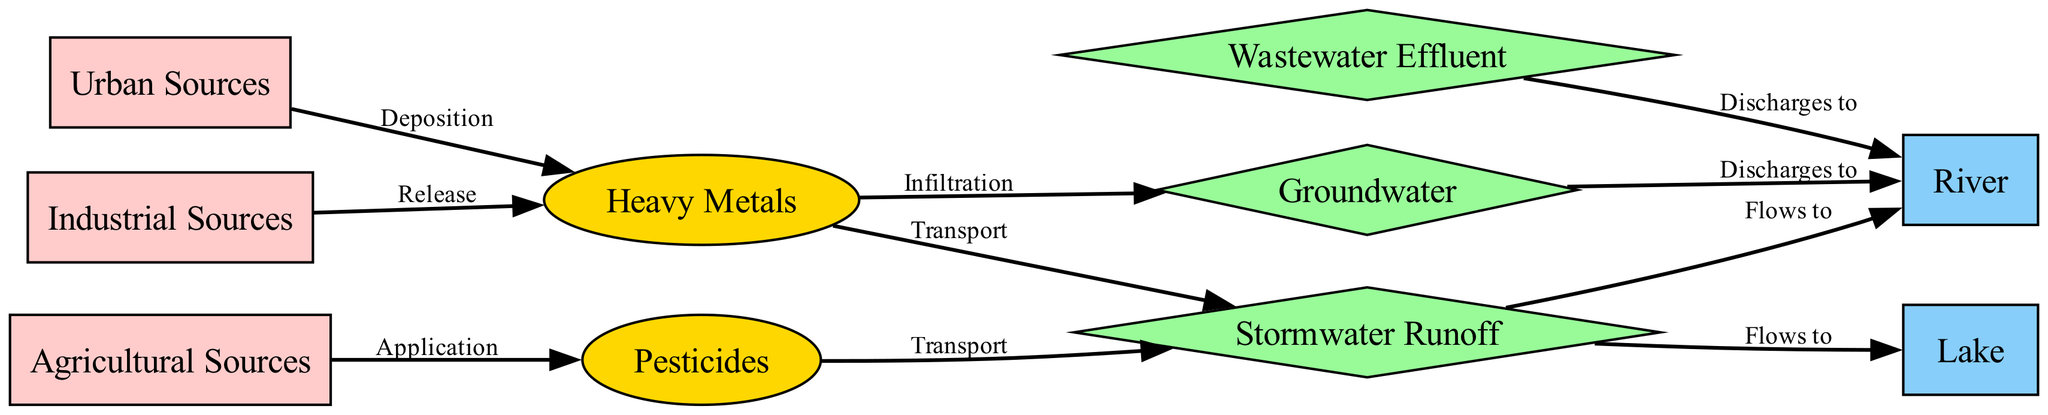What are the three types of sources listed in the diagram? The diagram indicates three types of sources: Industrial Sources, Agricultural Sources, and Urban Sources. These are displayed as nodes labeled clearly as such.
Answer: Industrial Sources, Agricultural Sources, Urban Sources How many contaminants are represented in the diagram? The diagram shows two contaminants: Heavy Metals and Pesticides. These contaminants are represented as distinct nodes in the visual.
Answer: 2 What type of pathway is used for transporting heavy metals? The diagram indicates that Heavy Metals are transported through the pathway labeled as Stormwater Runoff. This relationship is directly depicted by the connecting edge labeled "Transport."
Answer: Stormwater Runoff Which source is associated with pesticide application? According to the diagram, the Agricultural Sources node is linked to Pesticides through the edge labeled "Application," indicating that pesticides come specifically from agricultural practices.
Answer: Agricultural Sources From which pathways do the contaminants flow to the river? The diagram illustrates two pathways discharging into the river: run-off (Stormwater Runoff) and groundwater. The edges labeled "Flows to" and "Discharges to" establish these connections.
Answer: Runoff, Groundwater What contaminants are produced by industrial and urban sources? Industrial Sources release Heavy Metals, while Urban Sources deposit Heavy Metals. Both relationships are directly indicated by edges from their respective source nodes to the Heavy Metals contaminant node in the diagram.
Answer: Heavy Metals Which water bodies are affected by runoff? The diagram indicates that Stormwater Runoff flows into two water bodies: the River and the Lake. This is indicated by directed edges labeled "Flows to."
Answer: River, Lake How does wastewater affect the river? The diagram indicates that Wastewater Effluent discharges into the river, which is depicted by a directed edge labeled "Discharges to." This shows a direct impact of wastewater on the river.
Answer: Discharges to What is the relationship between groundwater and the river? The diagram shows that groundwater discharges into the river, indicated by an edge labeled "Discharges to" that connects the Groundwater node to the River node.
Answer: Discharges to 